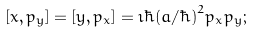Convert formula to latex. <formula><loc_0><loc_0><loc_500><loc_500>[ x , p _ { y } ] = [ y , p _ { x } ] = \imath \hbar { ( } a / \hbar { ) } ^ { 2 } p _ { x } p _ { y } ;</formula> 